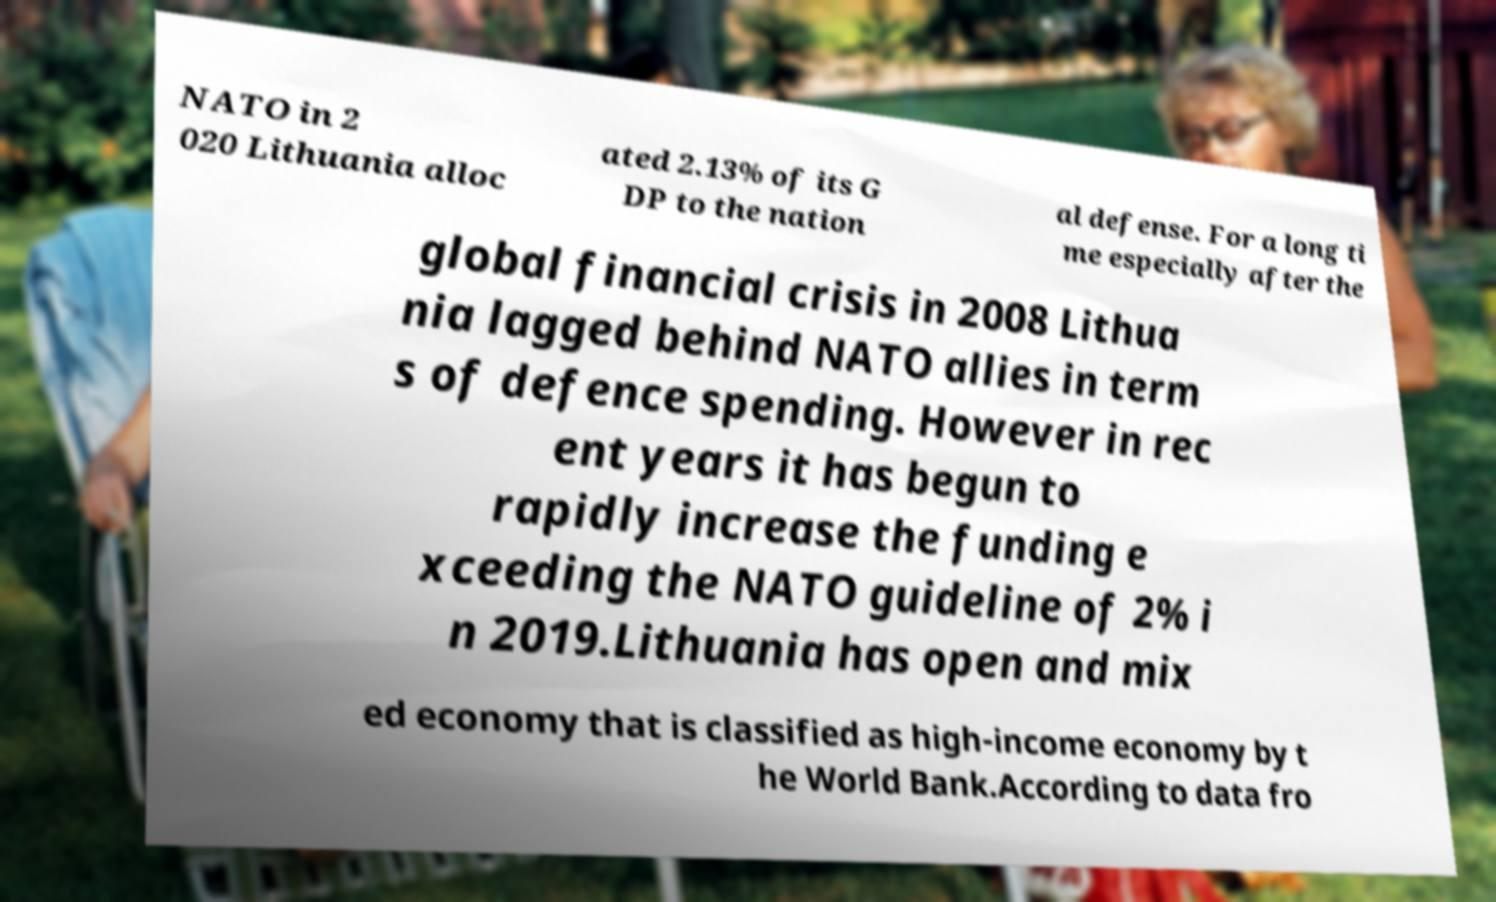There's text embedded in this image that I need extracted. Can you transcribe it verbatim? NATO in 2 020 Lithuania alloc ated 2.13% of its G DP to the nation al defense. For a long ti me especially after the global financial crisis in 2008 Lithua nia lagged behind NATO allies in term s of defence spending. However in rec ent years it has begun to rapidly increase the funding e xceeding the NATO guideline of 2% i n 2019.Lithuania has open and mix ed economy that is classified as high-income economy by t he World Bank.According to data fro 